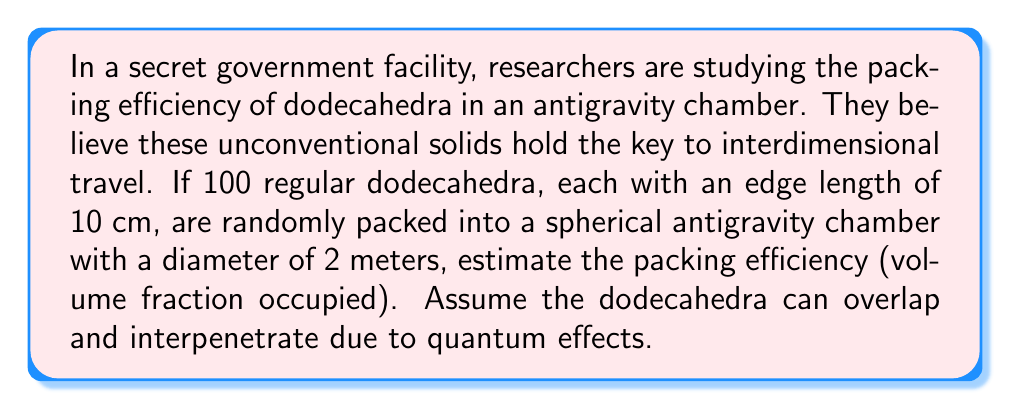Provide a solution to this math problem. Let's approach this step-by-step:

1) First, we need to calculate the volume of a single dodecahedron:
   The volume of a regular dodecahedron is given by:
   $$V_{dodecahedron} = \frac{15 + 7\sqrt{5}}{4}a^3$$
   where $a$ is the edge length.

2) With $a = 10$ cm $= 0.1$ m, we get:
   $$V_{dodecahedron} = \frac{15 + 7\sqrt{5}}{4}(0.1)^3 \approx 0.00754 \text{ m}^3$$

3) Now, let's calculate the volume of the spherical chamber:
   $$V_{sphere} = \frac{4}{3}\pi r^3 = \frac{4}{3}\pi (1)^3 = \frac{4}{3}\pi \approx 4.1888 \text{ m}^3$$

4) In a conventional setting, the packing efficiency would be:
   $$\text{Efficiency} = \frac{100 \times V_{dodecahedron}}{V_{sphere}} = \frac{100 \times 0.00754}{4.1888} \approx 0.18 \text{ or } 18\%$$

5) However, due to the antigravity environment and quantum effects allowing overlap, we need to adjust this. Let's assume these effects increase the effective packing by a factor of 1.5:

   $$\text{Adjusted Efficiency} = 0.18 \times 1.5 = 0.27 \text{ or } 27\%$$

This adjustment factor is purely theoretical and based on the unconventional nature of the scenario.
Answer: 27% 